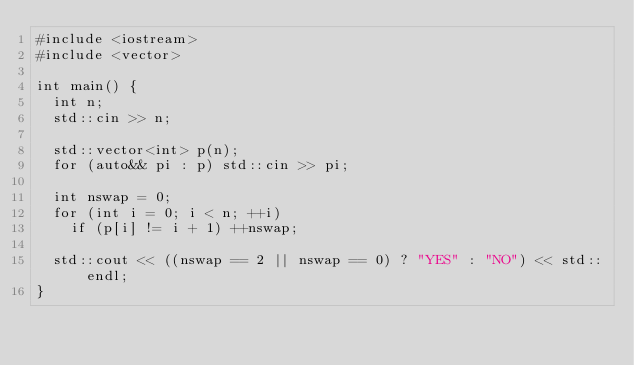<code> <loc_0><loc_0><loc_500><loc_500><_C++_>#include <iostream>
#include <vector>

int main() {
  int n;
  std::cin >> n;

  std::vector<int> p(n);
  for (auto&& pi : p) std::cin >> pi;

  int nswap = 0;
  for (int i = 0; i < n; ++i)
    if (p[i] != i + 1) ++nswap;

  std::cout << ((nswap == 2 || nswap == 0) ? "YES" : "NO") << std::endl;
}</code> 